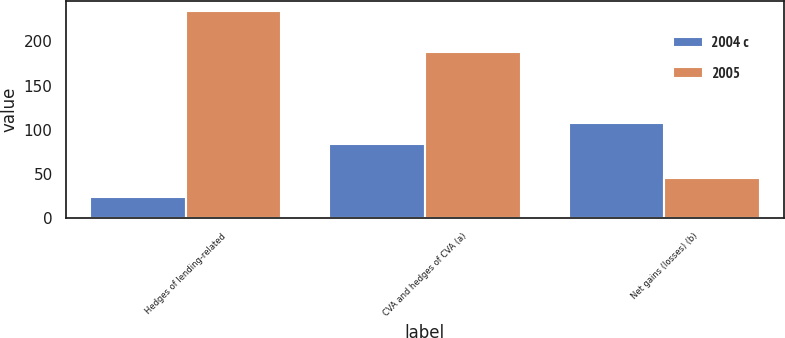Convert chart. <chart><loc_0><loc_0><loc_500><loc_500><stacked_bar_chart><ecel><fcel>Hedges of lending-related<fcel>CVA and hedges of CVA (a)<fcel>Net gains (losses) (b)<nl><fcel>2004 c<fcel>24<fcel>84<fcel>108<nl><fcel>2005<fcel>234<fcel>188<fcel>46<nl></chart> 